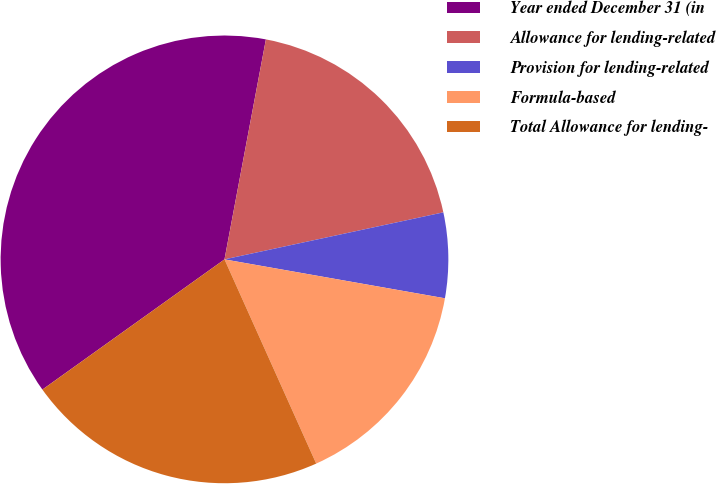Convert chart to OTSL. <chart><loc_0><loc_0><loc_500><loc_500><pie_chart><fcel>Year ended December 31 (in<fcel>Allowance for lending-related<fcel>Provision for lending-related<fcel>Formula-based<fcel>Total Allowance for lending-<nl><fcel>37.84%<fcel>18.67%<fcel>6.15%<fcel>15.5%<fcel>21.84%<nl></chart> 